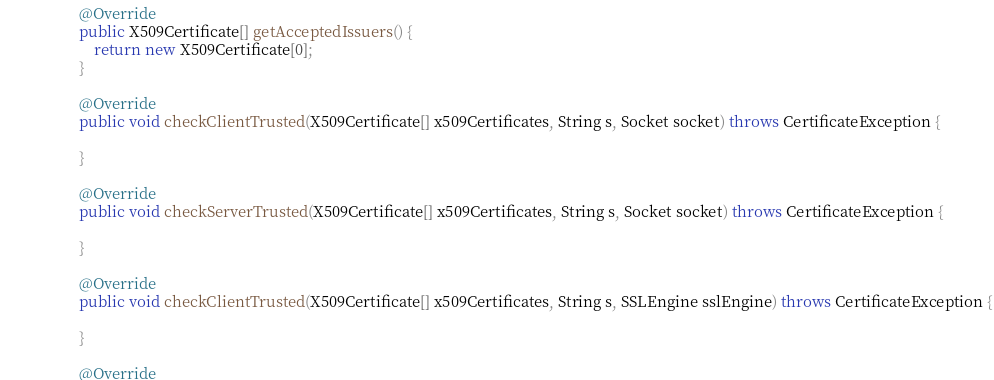Convert code to text. <code><loc_0><loc_0><loc_500><loc_500><_Java_>
                    @Override
                    public X509Certificate[] getAcceptedIssuers() {
                        return new X509Certificate[0];
                    }

                    @Override
                    public void checkClientTrusted(X509Certificate[] x509Certificates, String s, Socket socket) throws CertificateException {

                    }

                    @Override
                    public void checkServerTrusted(X509Certificate[] x509Certificates, String s, Socket socket) throws CertificateException {

                    }

                    @Override
                    public void checkClientTrusted(X509Certificate[] x509Certificates, String s, SSLEngine sslEngine) throws CertificateException {

                    }

                    @Override</code> 